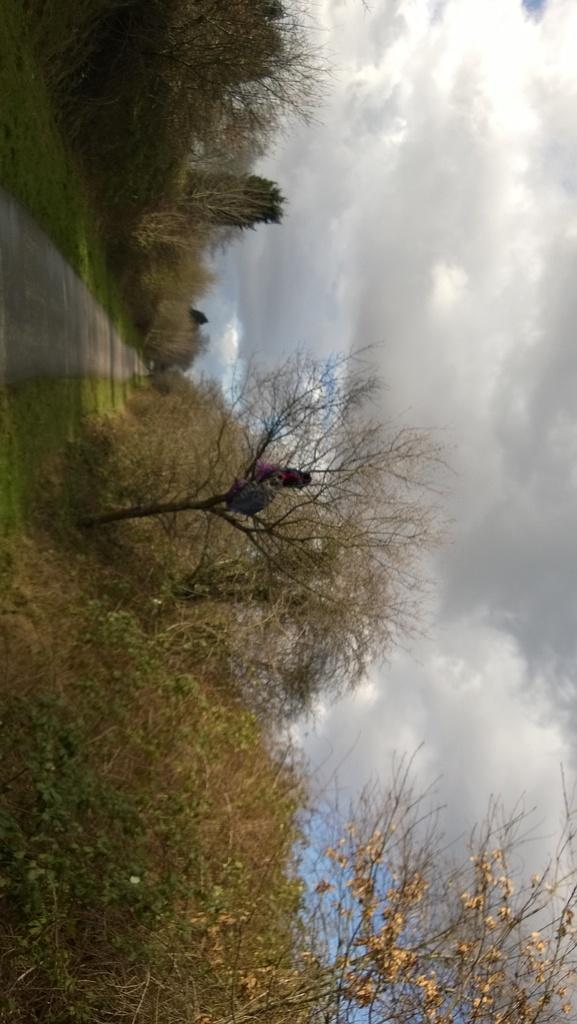What type of natural elements can be seen in the image? There are trees in the image. What part of the natural environment is visible in the image? The sky is visible in the image. What man-made feature can be seen in the image? There is a road in the image. What type of pencil can be seen in the image? There is no pencil present in the image. Can you tell me how many uncles are visible in the image? There are no people, including uncles, present in the image. 